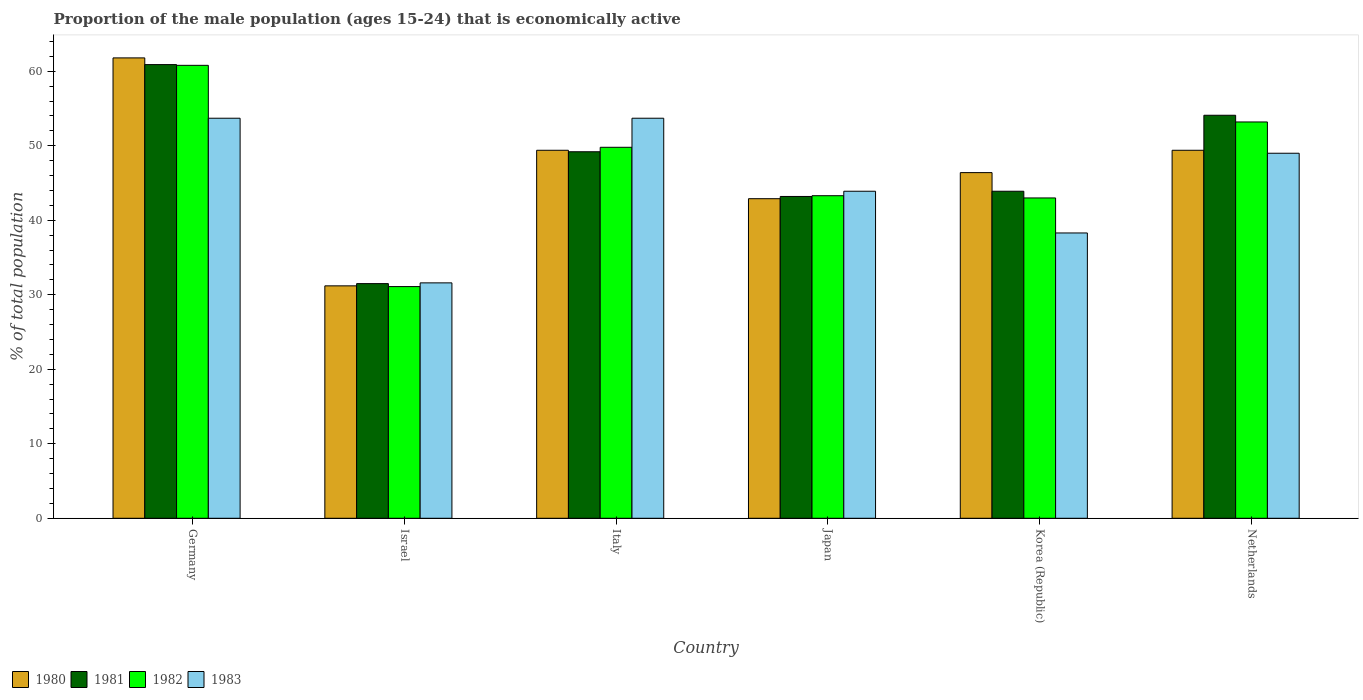Are the number of bars per tick equal to the number of legend labels?
Offer a very short reply. Yes. Are the number of bars on each tick of the X-axis equal?
Ensure brevity in your answer.  Yes. How many bars are there on the 5th tick from the left?
Your response must be concise. 4. What is the label of the 4th group of bars from the left?
Provide a short and direct response. Japan. In how many cases, is the number of bars for a given country not equal to the number of legend labels?
Provide a succinct answer. 0. Across all countries, what is the maximum proportion of the male population that is economically active in 1981?
Offer a very short reply. 60.9. Across all countries, what is the minimum proportion of the male population that is economically active in 1980?
Offer a very short reply. 31.2. In which country was the proportion of the male population that is economically active in 1981 maximum?
Provide a succinct answer. Germany. In which country was the proportion of the male population that is economically active in 1983 minimum?
Give a very brief answer. Israel. What is the total proportion of the male population that is economically active in 1980 in the graph?
Give a very brief answer. 281.1. What is the difference between the proportion of the male population that is economically active in 1981 in Japan and that in Korea (Republic)?
Ensure brevity in your answer.  -0.7. What is the difference between the proportion of the male population that is economically active in 1982 in Israel and the proportion of the male population that is economically active in 1981 in Netherlands?
Your answer should be very brief. -23. What is the average proportion of the male population that is economically active in 1982 per country?
Provide a short and direct response. 46.87. What is the difference between the proportion of the male population that is economically active of/in 1982 and proportion of the male population that is economically active of/in 1980 in Korea (Republic)?
Your response must be concise. -3.4. In how many countries, is the proportion of the male population that is economically active in 1981 greater than 6 %?
Keep it short and to the point. 6. What is the ratio of the proportion of the male population that is economically active in 1982 in Israel to that in Korea (Republic)?
Ensure brevity in your answer.  0.72. What is the difference between the highest and the lowest proportion of the male population that is economically active in 1983?
Keep it short and to the point. 22.1. In how many countries, is the proportion of the male population that is economically active in 1981 greater than the average proportion of the male population that is economically active in 1981 taken over all countries?
Keep it short and to the point. 3. Is it the case that in every country, the sum of the proportion of the male population that is economically active in 1981 and proportion of the male population that is economically active in 1983 is greater than the proportion of the male population that is economically active in 1982?
Make the answer very short. Yes. How many bars are there?
Ensure brevity in your answer.  24. Are all the bars in the graph horizontal?
Give a very brief answer. No. How many countries are there in the graph?
Your answer should be very brief. 6. What is the difference between two consecutive major ticks on the Y-axis?
Offer a terse response. 10. Does the graph contain any zero values?
Give a very brief answer. No. Where does the legend appear in the graph?
Keep it short and to the point. Bottom left. How many legend labels are there?
Provide a succinct answer. 4. What is the title of the graph?
Your answer should be very brief. Proportion of the male population (ages 15-24) that is economically active. Does "1970" appear as one of the legend labels in the graph?
Your answer should be compact. No. What is the label or title of the X-axis?
Provide a succinct answer. Country. What is the label or title of the Y-axis?
Ensure brevity in your answer.  % of total population. What is the % of total population of 1980 in Germany?
Keep it short and to the point. 61.8. What is the % of total population in 1981 in Germany?
Give a very brief answer. 60.9. What is the % of total population of 1982 in Germany?
Your answer should be compact. 60.8. What is the % of total population of 1983 in Germany?
Your answer should be very brief. 53.7. What is the % of total population in 1980 in Israel?
Provide a succinct answer. 31.2. What is the % of total population in 1981 in Israel?
Provide a succinct answer. 31.5. What is the % of total population in 1982 in Israel?
Provide a short and direct response. 31.1. What is the % of total population of 1983 in Israel?
Ensure brevity in your answer.  31.6. What is the % of total population in 1980 in Italy?
Give a very brief answer. 49.4. What is the % of total population in 1981 in Italy?
Provide a short and direct response. 49.2. What is the % of total population of 1982 in Italy?
Your answer should be very brief. 49.8. What is the % of total population of 1983 in Italy?
Provide a short and direct response. 53.7. What is the % of total population of 1980 in Japan?
Your answer should be compact. 42.9. What is the % of total population of 1981 in Japan?
Your answer should be very brief. 43.2. What is the % of total population in 1982 in Japan?
Give a very brief answer. 43.3. What is the % of total population in 1983 in Japan?
Your answer should be compact. 43.9. What is the % of total population of 1980 in Korea (Republic)?
Keep it short and to the point. 46.4. What is the % of total population of 1981 in Korea (Republic)?
Your answer should be very brief. 43.9. What is the % of total population of 1983 in Korea (Republic)?
Your response must be concise. 38.3. What is the % of total population of 1980 in Netherlands?
Make the answer very short. 49.4. What is the % of total population of 1981 in Netherlands?
Keep it short and to the point. 54.1. What is the % of total population in 1982 in Netherlands?
Make the answer very short. 53.2. Across all countries, what is the maximum % of total population of 1980?
Provide a short and direct response. 61.8. Across all countries, what is the maximum % of total population in 1981?
Your answer should be compact. 60.9. Across all countries, what is the maximum % of total population of 1982?
Keep it short and to the point. 60.8. Across all countries, what is the maximum % of total population in 1983?
Your answer should be very brief. 53.7. Across all countries, what is the minimum % of total population in 1980?
Ensure brevity in your answer.  31.2. Across all countries, what is the minimum % of total population of 1981?
Your response must be concise. 31.5. Across all countries, what is the minimum % of total population in 1982?
Your answer should be compact. 31.1. Across all countries, what is the minimum % of total population of 1983?
Your answer should be compact. 31.6. What is the total % of total population in 1980 in the graph?
Your answer should be very brief. 281.1. What is the total % of total population in 1981 in the graph?
Offer a terse response. 282.8. What is the total % of total population of 1982 in the graph?
Offer a terse response. 281.2. What is the total % of total population of 1983 in the graph?
Offer a very short reply. 270.2. What is the difference between the % of total population of 1980 in Germany and that in Israel?
Your answer should be compact. 30.6. What is the difference between the % of total population of 1981 in Germany and that in Israel?
Your response must be concise. 29.4. What is the difference between the % of total population in 1982 in Germany and that in Israel?
Your response must be concise. 29.7. What is the difference between the % of total population of 1983 in Germany and that in Israel?
Your answer should be compact. 22.1. What is the difference between the % of total population in 1980 in Germany and that in Italy?
Your response must be concise. 12.4. What is the difference between the % of total population in 1981 in Germany and that in Italy?
Your answer should be very brief. 11.7. What is the difference between the % of total population of 1980 in Germany and that in Japan?
Keep it short and to the point. 18.9. What is the difference between the % of total population of 1983 in Germany and that in Japan?
Keep it short and to the point. 9.8. What is the difference between the % of total population of 1980 in Germany and that in Korea (Republic)?
Ensure brevity in your answer.  15.4. What is the difference between the % of total population of 1981 in Germany and that in Korea (Republic)?
Your answer should be very brief. 17. What is the difference between the % of total population of 1982 in Germany and that in Korea (Republic)?
Provide a short and direct response. 17.8. What is the difference between the % of total population of 1983 in Germany and that in Korea (Republic)?
Provide a succinct answer. 15.4. What is the difference between the % of total population in 1981 in Germany and that in Netherlands?
Provide a succinct answer. 6.8. What is the difference between the % of total population in 1982 in Germany and that in Netherlands?
Your answer should be very brief. 7.6. What is the difference between the % of total population of 1983 in Germany and that in Netherlands?
Provide a succinct answer. 4.7. What is the difference between the % of total population of 1980 in Israel and that in Italy?
Ensure brevity in your answer.  -18.2. What is the difference between the % of total population in 1981 in Israel and that in Italy?
Make the answer very short. -17.7. What is the difference between the % of total population of 1982 in Israel and that in Italy?
Ensure brevity in your answer.  -18.7. What is the difference between the % of total population of 1983 in Israel and that in Italy?
Offer a terse response. -22.1. What is the difference between the % of total population of 1980 in Israel and that in Japan?
Offer a terse response. -11.7. What is the difference between the % of total population of 1980 in Israel and that in Korea (Republic)?
Offer a terse response. -15.2. What is the difference between the % of total population of 1981 in Israel and that in Korea (Republic)?
Offer a terse response. -12.4. What is the difference between the % of total population in 1982 in Israel and that in Korea (Republic)?
Keep it short and to the point. -11.9. What is the difference between the % of total population of 1980 in Israel and that in Netherlands?
Keep it short and to the point. -18.2. What is the difference between the % of total population of 1981 in Israel and that in Netherlands?
Offer a very short reply. -22.6. What is the difference between the % of total population in 1982 in Israel and that in Netherlands?
Your response must be concise. -22.1. What is the difference between the % of total population of 1983 in Israel and that in Netherlands?
Your answer should be compact. -17.4. What is the difference between the % of total population in 1980 in Italy and that in Japan?
Ensure brevity in your answer.  6.5. What is the difference between the % of total population in 1983 in Italy and that in Japan?
Your answer should be very brief. 9.8. What is the difference between the % of total population of 1982 in Italy and that in Korea (Republic)?
Your response must be concise. 6.8. What is the difference between the % of total population of 1983 in Italy and that in Korea (Republic)?
Your answer should be compact. 15.4. What is the difference between the % of total population in 1980 in Italy and that in Netherlands?
Ensure brevity in your answer.  0. What is the difference between the % of total population in 1981 in Japan and that in Korea (Republic)?
Ensure brevity in your answer.  -0.7. What is the difference between the % of total population of 1982 in Japan and that in Korea (Republic)?
Offer a very short reply. 0.3. What is the difference between the % of total population of 1980 in Japan and that in Netherlands?
Offer a very short reply. -6.5. What is the difference between the % of total population of 1981 in Japan and that in Netherlands?
Keep it short and to the point. -10.9. What is the difference between the % of total population of 1982 in Japan and that in Netherlands?
Make the answer very short. -9.9. What is the difference between the % of total population in 1983 in Japan and that in Netherlands?
Provide a succinct answer. -5.1. What is the difference between the % of total population in 1980 in Korea (Republic) and that in Netherlands?
Your answer should be compact. -3. What is the difference between the % of total population in 1981 in Korea (Republic) and that in Netherlands?
Make the answer very short. -10.2. What is the difference between the % of total population in 1980 in Germany and the % of total population in 1981 in Israel?
Offer a terse response. 30.3. What is the difference between the % of total population of 1980 in Germany and the % of total population of 1982 in Israel?
Make the answer very short. 30.7. What is the difference between the % of total population of 1980 in Germany and the % of total population of 1983 in Israel?
Your answer should be very brief. 30.2. What is the difference between the % of total population in 1981 in Germany and the % of total population in 1982 in Israel?
Give a very brief answer. 29.8. What is the difference between the % of total population of 1981 in Germany and the % of total population of 1983 in Israel?
Provide a short and direct response. 29.3. What is the difference between the % of total population in 1982 in Germany and the % of total population in 1983 in Israel?
Keep it short and to the point. 29.2. What is the difference between the % of total population in 1980 in Germany and the % of total population in 1982 in Italy?
Keep it short and to the point. 12. What is the difference between the % of total population of 1980 in Germany and the % of total population of 1983 in Italy?
Give a very brief answer. 8.1. What is the difference between the % of total population in 1981 in Germany and the % of total population in 1982 in Italy?
Ensure brevity in your answer.  11.1. What is the difference between the % of total population of 1981 in Germany and the % of total population of 1983 in Italy?
Offer a terse response. 7.2. What is the difference between the % of total population in 1980 in Germany and the % of total population in 1981 in Japan?
Keep it short and to the point. 18.6. What is the difference between the % of total population in 1980 in Germany and the % of total population in 1983 in Japan?
Ensure brevity in your answer.  17.9. What is the difference between the % of total population in 1980 in Germany and the % of total population in 1983 in Korea (Republic)?
Make the answer very short. 23.5. What is the difference between the % of total population in 1981 in Germany and the % of total population in 1982 in Korea (Republic)?
Keep it short and to the point. 17.9. What is the difference between the % of total population in 1981 in Germany and the % of total population in 1983 in Korea (Republic)?
Provide a short and direct response. 22.6. What is the difference between the % of total population of 1980 in Germany and the % of total population of 1983 in Netherlands?
Offer a very short reply. 12.8. What is the difference between the % of total population of 1981 in Germany and the % of total population of 1982 in Netherlands?
Offer a very short reply. 7.7. What is the difference between the % of total population of 1982 in Germany and the % of total population of 1983 in Netherlands?
Offer a very short reply. 11.8. What is the difference between the % of total population of 1980 in Israel and the % of total population of 1981 in Italy?
Give a very brief answer. -18. What is the difference between the % of total population in 1980 in Israel and the % of total population in 1982 in Italy?
Keep it short and to the point. -18.6. What is the difference between the % of total population in 1980 in Israel and the % of total population in 1983 in Italy?
Keep it short and to the point. -22.5. What is the difference between the % of total population of 1981 in Israel and the % of total population of 1982 in Italy?
Make the answer very short. -18.3. What is the difference between the % of total population in 1981 in Israel and the % of total population in 1983 in Italy?
Your answer should be compact. -22.2. What is the difference between the % of total population in 1982 in Israel and the % of total population in 1983 in Italy?
Provide a succinct answer. -22.6. What is the difference between the % of total population in 1980 in Israel and the % of total population in 1981 in Japan?
Make the answer very short. -12. What is the difference between the % of total population of 1981 in Israel and the % of total population of 1982 in Japan?
Ensure brevity in your answer.  -11.8. What is the difference between the % of total population of 1980 in Israel and the % of total population of 1981 in Korea (Republic)?
Provide a short and direct response. -12.7. What is the difference between the % of total population of 1980 in Israel and the % of total population of 1982 in Korea (Republic)?
Keep it short and to the point. -11.8. What is the difference between the % of total population of 1981 in Israel and the % of total population of 1983 in Korea (Republic)?
Ensure brevity in your answer.  -6.8. What is the difference between the % of total population in 1982 in Israel and the % of total population in 1983 in Korea (Republic)?
Your answer should be very brief. -7.2. What is the difference between the % of total population of 1980 in Israel and the % of total population of 1981 in Netherlands?
Give a very brief answer. -22.9. What is the difference between the % of total population of 1980 in Israel and the % of total population of 1983 in Netherlands?
Ensure brevity in your answer.  -17.8. What is the difference between the % of total population in 1981 in Israel and the % of total population in 1982 in Netherlands?
Provide a succinct answer. -21.7. What is the difference between the % of total population in 1981 in Israel and the % of total population in 1983 in Netherlands?
Your answer should be very brief. -17.5. What is the difference between the % of total population of 1982 in Israel and the % of total population of 1983 in Netherlands?
Keep it short and to the point. -17.9. What is the difference between the % of total population in 1980 in Italy and the % of total population in 1981 in Japan?
Offer a very short reply. 6.2. What is the difference between the % of total population in 1980 in Italy and the % of total population in 1982 in Japan?
Give a very brief answer. 6.1. What is the difference between the % of total population in 1980 in Italy and the % of total population in 1983 in Japan?
Provide a short and direct response. 5.5. What is the difference between the % of total population in 1982 in Italy and the % of total population in 1983 in Japan?
Offer a very short reply. 5.9. What is the difference between the % of total population in 1980 in Italy and the % of total population in 1982 in Korea (Republic)?
Provide a short and direct response. 6.4. What is the difference between the % of total population of 1981 in Italy and the % of total population of 1982 in Korea (Republic)?
Make the answer very short. 6.2. What is the difference between the % of total population of 1981 in Italy and the % of total population of 1983 in Korea (Republic)?
Offer a very short reply. 10.9. What is the difference between the % of total population of 1982 in Italy and the % of total population of 1983 in Korea (Republic)?
Offer a very short reply. 11.5. What is the difference between the % of total population in 1980 in Italy and the % of total population in 1983 in Netherlands?
Offer a terse response. 0.4. What is the difference between the % of total population in 1981 in Italy and the % of total population in 1983 in Netherlands?
Your answer should be very brief. 0.2. What is the difference between the % of total population in 1982 in Italy and the % of total population in 1983 in Netherlands?
Provide a succinct answer. 0.8. What is the difference between the % of total population in 1981 in Japan and the % of total population in 1983 in Korea (Republic)?
Provide a succinct answer. 4.9. What is the difference between the % of total population of 1982 in Japan and the % of total population of 1983 in Korea (Republic)?
Offer a very short reply. 5. What is the difference between the % of total population in 1980 in Japan and the % of total population in 1982 in Netherlands?
Provide a succinct answer. -10.3. What is the difference between the % of total population of 1980 in Japan and the % of total population of 1983 in Netherlands?
Keep it short and to the point. -6.1. What is the difference between the % of total population in 1981 in Japan and the % of total population in 1982 in Netherlands?
Your response must be concise. -10. What is the difference between the % of total population in 1981 in Korea (Republic) and the % of total population in 1982 in Netherlands?
Give a very brief answer. -9.3. What is the average % of total population of 1980 per country?
Offer a terse response. 46.85. What is the average % of total population of 1981 per country?
Keep it short and to the point. 47.13. What is the average % of total population in 1982 per country?
Provide a succinct answer. 46.87. What is the average % of total population of 1983 per country?
Provide a short and direct response. 45.03. What is the difference between the % of total population in 1980 and % of total population in 1983 in Germany?
Your answer should be compact. 8.1. What is the difference between the % of total population of 1981 and % of total population of 1982 in Germany?
Offer a very short reply. 0.1. What is the difference between the % of total population in 1981 and % of total population in 1983 in Germany?
Your answer should be compact. 7.2. What is the difference between the % of total population of 1980 and % of total population of 1981 in Israel?
Offer a very short reply. -0.3. What is the difference between the % of total population of 1980 and % of total population of 1982 in Israel?
Ensure brevity in your answer.  0.1. What is the difference between the % of total population in 1980 and % of total population in 1983 in Israel?
Your answer should be compact. -0.4. What is the difference between the % of total population of 1981 and % of total population of 1982 in Israel?
Your response must be concise. 0.4. What is the difference between the % of total population in 1980 and % of total population in 1981 in Italy?
Offer a terse response. 0.2. What is the difference between the % of total population in 1980 and % of total population in 1983 in Italy?
Provide a succinct answer. -4.3. What is the difference between the % of total population in 1980 and % of total population in 1981 in Japan?
Offer a terse response. -0.3. What is the difference between the % of total population of 1980 and % of total population of 1982 in Japan?
Provide a short and direct response. -0.4. What is the difference between the % of total population of 1980 and % of total population of 1983 in Japan?
Your answer should be very brief. -1. What is the difference between the % of total population of 1981 and % of total population of 1982 in Japan?
Keep it short and to the point. -0.1. What is the difference between the % of total population in 1981 and % of total population in 1983 in Japan?
Ensure brevity in your answer.  -0.7. What is the difference between the % of total population of 1980 and % of total population of 1981 in Korea (Republic)?
Offer a terse response. 2.5. What is the difference between the % of total population in 1980 and % of total population in 1982 in Korea (Republic)?
Offer a terse response. 3.4. What is the difference between the % of total population in 1982 and % of total population in 1983 in Korea (Republic)?
Your response must be concise. 4.7. What is the difference between the % of total population of 1980 and % of total population of 1982 in Netherlands?
Your answer should be very brief. -3.8. What is the difference between the % of total population in 1980 and % of total population in 1983 in Netherlands?
Provide a succinct answer. 0.4. What is the ratio of the % of total population of 1980 in Germany to that in Israel?
Give a very brief answer. 1.98. What is the ratio of the % of total population of 1981 in Germany to that in Israel?
Provide a succinct answer. 1.93. What is the ratio of the % of total population of 1982 in Germany to that in Israel?
Ensure brevity in your answer.  1.96. What is the ratio of the % of total population of 1983 in Germany to that in Israel?
Your answer should be compact. 1.7. What is the ratio of the % of total population of 1980 in Germany to that in Italy?
Provide a short and direct response. 1.25. What is the ratio of the % of total population in 1981 in Germany to that in Italy?
Offer a very short reply. 1.24. What is the ratio of the % of total population in 1982 in Germany to that in Italy?
Your response must be concise. 1.22. What is the ratio of the % of total population in 1980 in Germany to that in Japan?
Keep it short and to the point. 1.44. What is the ratio of the % of total population of 1981 in Germany to that in Japan?
Provide a succinct answer. 1.41. What is the ratio of the % of total population in 1982 in Germany to that in Japan?
Give a very brief answer. 1.4. What is the ratio of the % of total population in 1983 in Germany to that in Japan?
Offer a very short reply. 1.22. What is the ratio of the % of total population of 1980 in Germany to that in Korea (Republic)?
Provide a succinct answer. 1.33. What is the ratio of the % of total population in 1981 in Germany to that in Korea (Republic)?
Offer a terse response. 1.39. What is the ratio of the % of total population in 1982 in Germany to that in Korea (Republic)?
Your answer should be compact. 1.41. What is the ratio of the % of total population in 1983 in Germany to that in Korea (Republic)?
Your response must be concise. 1.4. What is the ratio of the % of total population in 1980 in Germany to that in Netherlands?
Keep it short and to the point. 1.25. What is the ratio of the % of total population of 1981 in Germany to that in Netherlands?
Provide a short and direct response. 1.13. What is the ratio of the % of total population of 1982 in Germany to that in Netherlands?
Your response must be concise. 1.14. What is the ratio of the % of total population in 1983 in Germany to that in Netherlands?
Keep it short and to the point. 1.1. What is the ratio of the % of total population of 1980 in Israel to that in Italy?
Provide a succinct answer. 0.63. What is the ratio of the % of total population in 1981 in Israel to that in Italy?
Your response must be concise. 0.64. What is the ratio of the % of total population in 1982 in Israel to that in Italy?
Ensure brevity in your answer.  0.62. What is the ratio of the % of total population of 1983 in Israel to that in Italy?
Offer a terse response. 0.59. What is the ratio of the % of total population in 1980 in Israel to that in Japan?
Your answer should be compact. 0.73. What is the ratio of the % of total population in 1981 in Israel to that in Japan?
Offer a terse response. 0.73. What is the ratio of the % of total population of 1982 in Israel to that in Japan?
Offer a terse response. 0.72. What is the ratio of the % of total population of 1983 in Israel to that in Japan?
Give a very brief answer. 0.72. What is the ratio of the % of total population in 1980 in Israel to that in Korea (Republic)?
Give a very brief answer. 0.67. What is the ratio of the % of total population of 1981 in Israel to that in Korea (Republic)?
Provide a succinct answer. 0.72. What is the ratio of the % of total population in 1982 in Israel to that in Korea (Republic)?
Provide a succinct answer. 0.72. What is the ratio of the % of total population of 1983 in Israel to that in Korea (Republic)?
Keep it short and to the point. 0.83. What is the ratio of the % of total population in 1980 in Israel to that in Netherlands?
Give a very brief answer. 0.63. What is the ratio of the % of total population of 1981 in Israel to that in Netherlands?
Make the answer very short. 0.58. What is the ratio of the % of total population in 1982 in Israel to that in Netherlands?
Offer a very short reply. 0.58. What is the ratio of the % of total population in 1983 in Israel to that in Netherlands?
Offer a very short reply. 0.64. What is the ratio of the % of total population of 1980 in Italy to that in Japan?
Keep it short and to the point. 1.15. What is the ratio of the % of total population of 1981 in Italy to that in Japan?
Make the answer very short. 1.14. What is the ratio of the % of total population in 1982 in Italy to that in Japan?
Keep it short and to the point. 1.15. What is the ratio of the % of total population in 1983 in Italy to that in Japan?
Give a very brief answer. 1.22. What is the ratio of the % of total population in 1980 in Italy to that in Korea (Republic)?
Offer a very short reply. 1.06. What is the ratio of the % of total population in 1981 in Italy to that in Korea (Republic)?
Offer a very short reply. 1.12. What is the ratio of the % of total population of 1982 in Italy to that in Korea (Republic)?
Provide a short and direct response. 1.16. What is the ratio of the % of total population of 1983 in Italy to that in Korea (Republic)?
Your answer should be compact. 1.4. What is the ratio of the % of total population in 1981 in Italy to that in Netherlands?
Offer a very short reply. 0.91. What is the ratio of the % of total population in 1982 in Italy to that in Netherlands?
Ensure brevity in your answer.  0.94. What is the ratio of the % of total population of 1983 in Italy to that in Netherlands?
Provide a succinct answer. 1.1. What is the ratio of the % of total population of 1980 in Japan to that in Korea (Republic)?
Provide a succinct answer. 0.92. What is the ratio of the % of total population of 1981 in Japan to that in Korea (Republic)?
Ensure brevity in your answer.  0.98. What is the ratio of the % of total population in 1983 in Japan to that in Korea (Republic)?
Offer a very short reply. 1.15. What is the ratio of the % of total population of 1980 in Japan to that in Netherlands?
Your answer should be very brief. 0.87. What is the ratio of the % of total population of 1981 in Japan to that in Netherlands?
Keep it short and to the point. 0.8. What is the ratio of the % of total population of 1982 in Japan to that in Netherlands?
Your answer should be very brief. 0.81. What is the ratio of the % of total population in 1983 in Japan to that in Netherlands?
Provide a short and direct response. 0.9. What is the ratio of the % of total population of 1980 in Korea (Republic) to that in Netherlands?
Keep it short and to the point. 0.94. What is the ratio of the % of total population of 1981 in Korea (Republic) to that in Netherlands?
Give a very brief answer. 0.81. What is the ratio of the % of total population of 1982 in Korea (Republic) to that in Netherlands?
Provide a succinct answer. 0.81. What is the ratio of the % of total population of 1983 in Korea (Republic) to that in Netherlands?
Your response must be concise. 0.78. What is the difference between the highest and the second highest % of total population in 1980?
Make the answer very short. 12.4. What is the difference between the highest and the second highest % of total population in 1982?
Give a very brief answer. 7.6. What is the difference between the highest and the second highest % of total population in 1983?
Give a very brief answer. 0. What is the difference between the highest and the lowest % of total population of 1980?
Ensure brevity in your answer.  30.6. What is the difference between the highest and the lowest % of total population of 1981?
Offer a terse response. 29.4. What is the difference between the highest and the lowest % of total population of 1982?
Keep it short and to the point. 29.7. What is the difference between the highest and the lowest % of total population of 1983?
Your response must be concise. 22.1. 